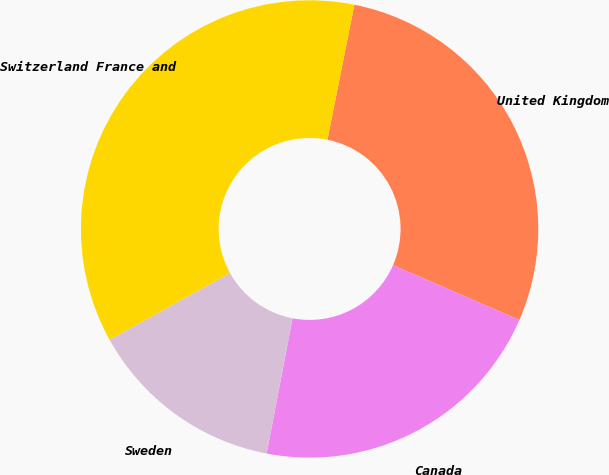Convert chart to OTSL. <chart><loc_0><loc_0><loc_500><loc_500><pie_chart><fcel>United Kingdom<fcel>Canada<fcel>Sweden<fcel>Switzerland France and<nl><fcel>28.38%<fcel>21.49%<fcel>13.94%<fcel>36.19%<nl></chart> 